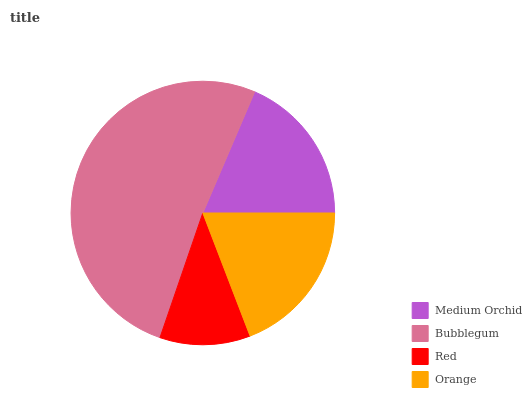Is Red the minimum?
Answer yes or no. Yes. Is Bubblegum the maximum?
Answer yes or no. Yes. Is Bubblegum the minimum?
Answer yes or no. No. Is Red the maximum?
Answer yes or no. No. Is Bubblegum greater than Red?
Answer yes or no. Yes. Is Red less than Bubblegum?
Answer yes or no. Yes. Is Red greater than Bubblegum?
Answer yes or no. No. Is Bubblegum less than Red?
Answer yes or no. No. Is Orange the high median?
Answer yes or no. Yes. Is Medium Orchid the low median?
Answer yes or no. Yes. Is Medium Orchid the high median?
Answer yes or no. No. Is Red the low median?
Answer yes or no. No. 